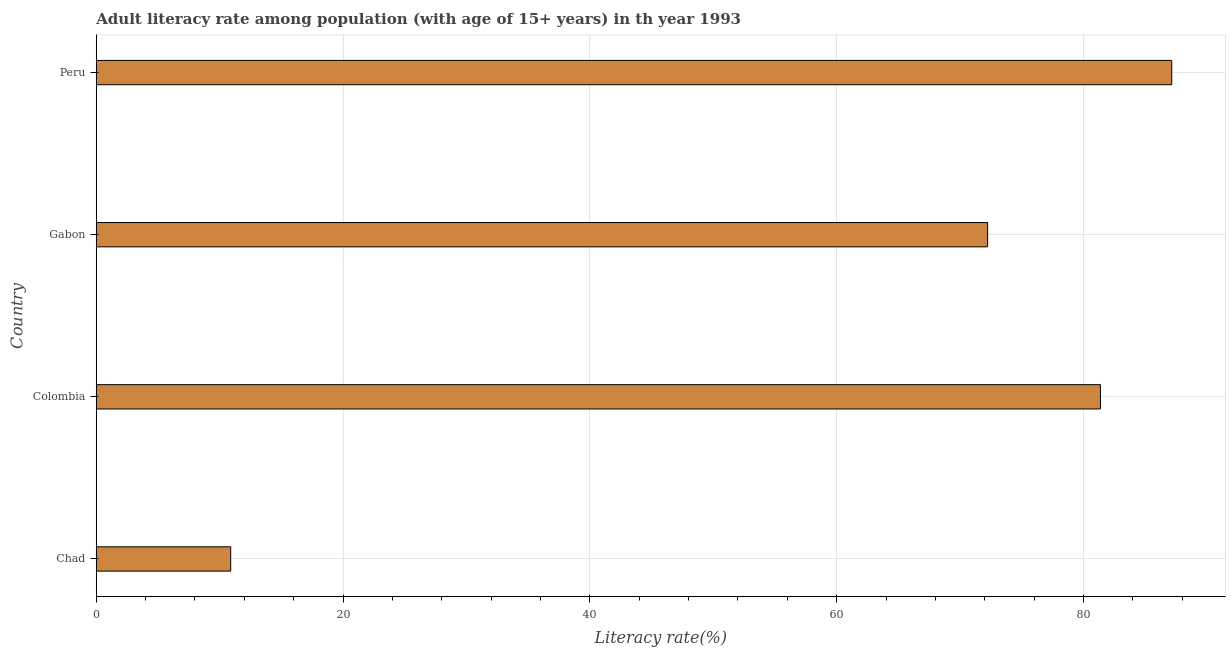Does the graph contain grids?
Offer a very short reply. Yes. What is the title of the graph?
Your answer should be compact. Adult literacy rate among population (with age of 15+ years) in th year 1993. What is the label or title of the X-axis?
Keep it short and to the point. Literacy rate(%). What is the label or title of the Y-axis?
Provide a succinct answer. Country. What is the adult literacy rate in Gabon?
Your answer should be compact. 72.23. Across all countries, what is the maximum adult literacy rate?
Offer a very short reply. 87.15. Across all countries, what is the minimum adult literacy rate?
Your response must be concise. 10.89. In which country was the adult literacy rate maximum?
Provide a short and direct response. Peru. In which country was the adult literacy rate minimum?
Offer a terse response. Chad. What is the sum of the adult literacy rate?
Ensure brevity in your answer.  251.65. What is the difference between the adult literacy rate in Colombia and Gabon?
Keep it short and to the point. 9.14. What is the average adult literacy rate per country?
Keep it short and to the point. 62.91. What is the median adult literacy rate?
Give a very brief answer. 76.8. In how many countries, is the adult literacy rate greater than 24 %?
Your answer should be very brief. 3. Is the adult literacy rate in Colombia less than that in Peru?
Make the answer very short. Yes. What is the difference between the highest and the second highest adult literacy rate?
Give a very brief answer. 5.78. What is the difference between the highest and the lowest adult literacy rate?
Offer a terse response. 76.26. In how many countries, is the adult literacy rate greater than the average adult literacy rate taken over all countries?
Make the answer very short. 3. Are all the bars in the graph horizontal?
Your answer should be very brief. Yes. What is the difference between two consecutive major ticks on the X-axis?
Provide a succinct answer. 20. What is the Literacy rate(%) in Chad?
Ensure brevity in your answer.  10.89. What is the Literacy rate(%) in Colombia?
Ensure brevity in your answer.  81.38. What is the Literacy rate(%) in Gabon?
Your answer should be very brief. 72.23. What is the Literacy rate(%) of Peru?
Give a very brief answer. 87.15. What is the difference between the Literacy rate(%) in Chad and Colombia?
Give a very brief answer. -70.48. What is the difference between the Literacy rate(%) in Chad and Gabon?
Provide a short and direct response. -61.34. What is the difference between the Literacy rate(%) in Chad and Peru?
Your response must be concise. -76.26. What is the difference between the Literacy rate(%) in Colombia and Gabon?
Offer a very short reply. 9.14. What is the difference between the Literacy rate(%) in Colombia and Peru?
Offer a very short reply. -5.78. What is the difference between the Literacy rate(%) in Gabon and Peru?
Provide a short and direct response. -14.92. What is the ratio of the Literacy rate(%) in Chad to that in Colombia?
Give a very brief answer. 0.13. What is the ratio of the Literacy rate(%) in Chad to that in Gabon?
Offer a very short reply. 0.15. What is the ratio of the Literacy rate(%) in Chad to that in Peru?
Your answer should be compact. 0.12. What is the ratio of the Literacy rate(%) in Colombia to that in Gabon?
Provide a short and direct response. 1.13. What is the ratio of the Literacy rate(%) in Colombia to that in Peru?
Your response must be concise. 0.93. What is the ratio of the Literacy rate(%) in Gabon to that in Peru?
Ensure brevity in your answer.  0.83. 